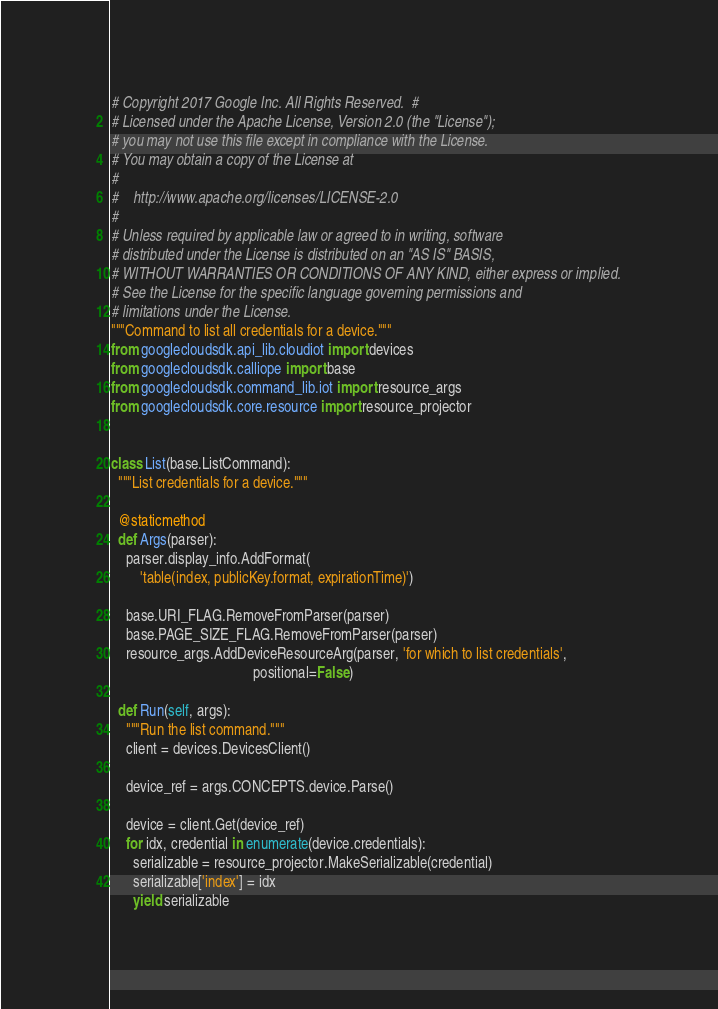<code> <loc_0><loc_0><loc_500><loc_500><_Python_># Copyright 2017 Google Inc. All Rights Reserved.  #
# Licensed under the Apache License, Version 2.0 (the "License");
# you may not use this file except in compliance with the License.
# You may obtain a copy of the License at
#
#    http://www.apache.org/licenses/LICENSE-2.0
#
# Unless required by applicable law or agreed to in writing, software
# distributed under the License is distributed on an "AS IS" BASIS,
# WITHOUT WARRANTIES OR CONDITIONS OF ANY KIND, either express or implied.
# See the License for the specific language governing permissions and
# limitations under the License.
"""Command to list all credentials for a device."""
from googlecloudsdk.api_lib.cloudiot import devices
from googlecloudsdk.calliope import base
from googlecloudsdk.command_lib.iot import resource_args
from googlecloudsdk.core.resource import resource_projector


class List(base.ListCommand):
  """List credentials for a device."""

  @staticmethod
  def Args(parser):
    parser.display_info.AddFormat(
        'table(index, publicKey.format, expirationTime)')

    base.URI_FLAG.RemoveFromParser(parser)
    base.PAGE_SIZE_FLAG.RemoveFromParser(parser)
    resource_args.AddDeviceResourceArg(parser, 'for which to list credentials',
                                       positional=False)

  def Run(self, args):
    """Run the list command."""
    client = devices.DevicesClient()

    device_ref = args.CONCEPTS.device.Parse()

    device = client.Get(device_ref)
    for idx, credential in enumerate(device.credentials):
      serializable = resource_projector.MakeSerializable(credential)
      serializable['index'] = idx
      yield serializable
</code> 